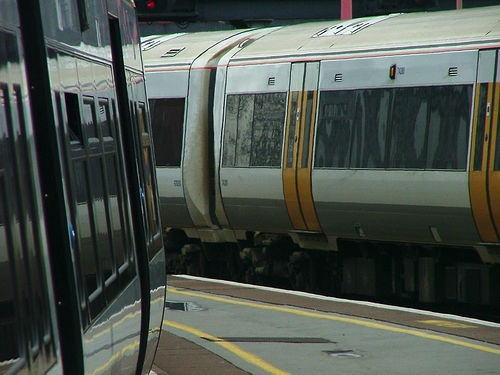Describe the objects in this image and their specific colors. I can see train in gray, black, darkgray, and lightgray tones and train in gray, black, darkgray, and teal tones in this image. 